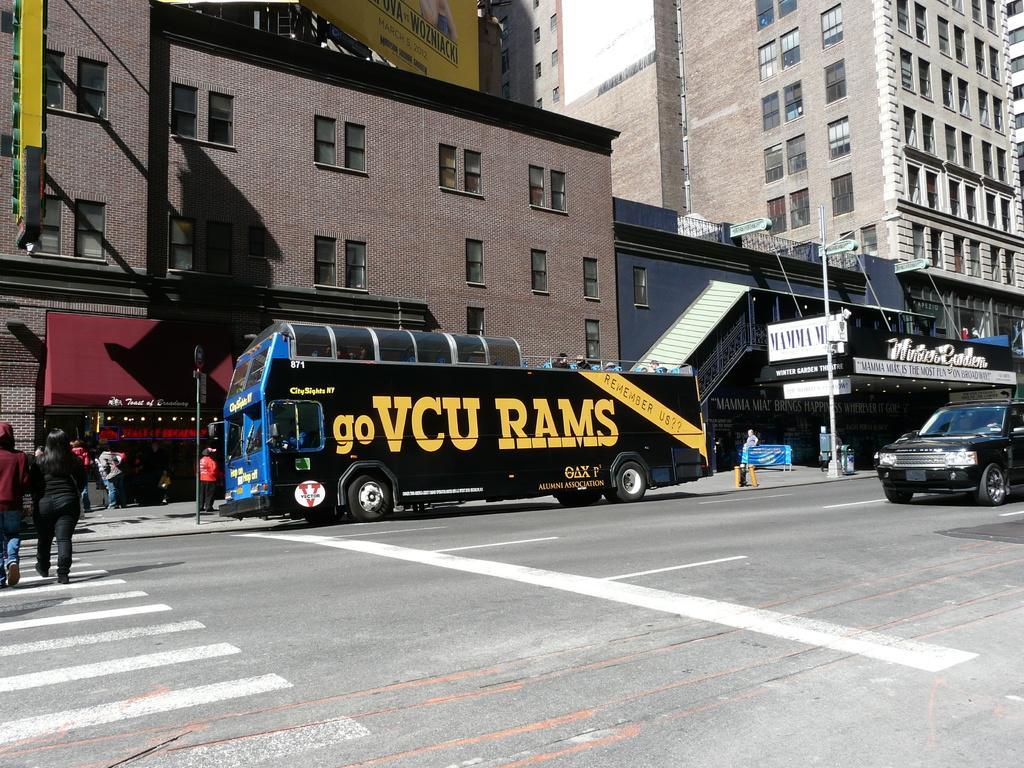Please provide a concise description of this image. In this image we can see there are buildings. And there are vehicles on the road and there are people walking on the road. There is a pole, street light, board and the sky. 